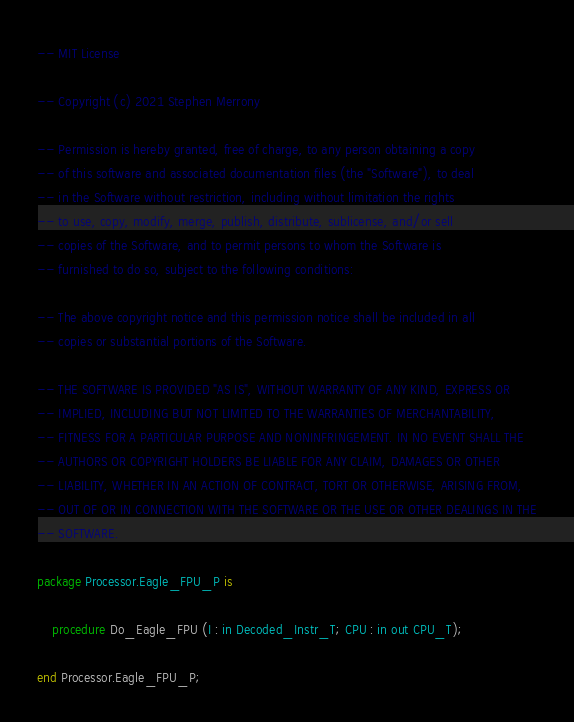<code> <loc_0><loc_0><loc_500><loc_500><_Ada_>-- MIT License

-- Copyright (c) 2021 Stephen Merrony

-- Permission is hereby granted, free of charge, to any person obtaining a copy
-- of this software and associated documentation files (the "Software"), to deal
-- in the Software without restriction, including without limitation the rights
-- to use, copy, modify, merge, publish, distribute, sublicense, and/or sell
-- copies of the Software, and to permit persons to whom the Software is
-- furnished to do so, subject to the following conditions:

-- The above copyright notice and this permission notice shall be included in all
-- copies or substantial portions of the Software.

-- THE SOFTWARE IS PROVIDED "AS IS", WITHOUT WARRANTY OF ANY KIND, EXPRESS OR
-- IMPLIED, INCLUDING BUT NOT LIMITED TO THE WARRANTIES OF MERCHANTABILITY,
-- FITNESS FOR A PARTICULAR PURPOSE AND NONINFRINGEMENT. IN NO EVENT SHALL THE
-- AUTHORS OR COPYRIGHT HOLDERS BE LIABLE FOR ANY CLAIM, DAMAGES OR OTHER
-- LIABILITY, WHETHER IN AN ACTION OF CONTRACT, TORT OR OTHERWISE, ARISING FROM,
-- OUT OF OR IN CONNECTION WITH THE SOFTWARE OR THE USE OR OTHER DEALINGS IN THE
-- SOFTWARE.

package Processor.Eagle_FPU_P is

    procedure Do_Eagle_FPU (I : in Decoded_Instr_T; CPU : in out CPU_T);

end Processor.Eagle_FPU_P;</code> 